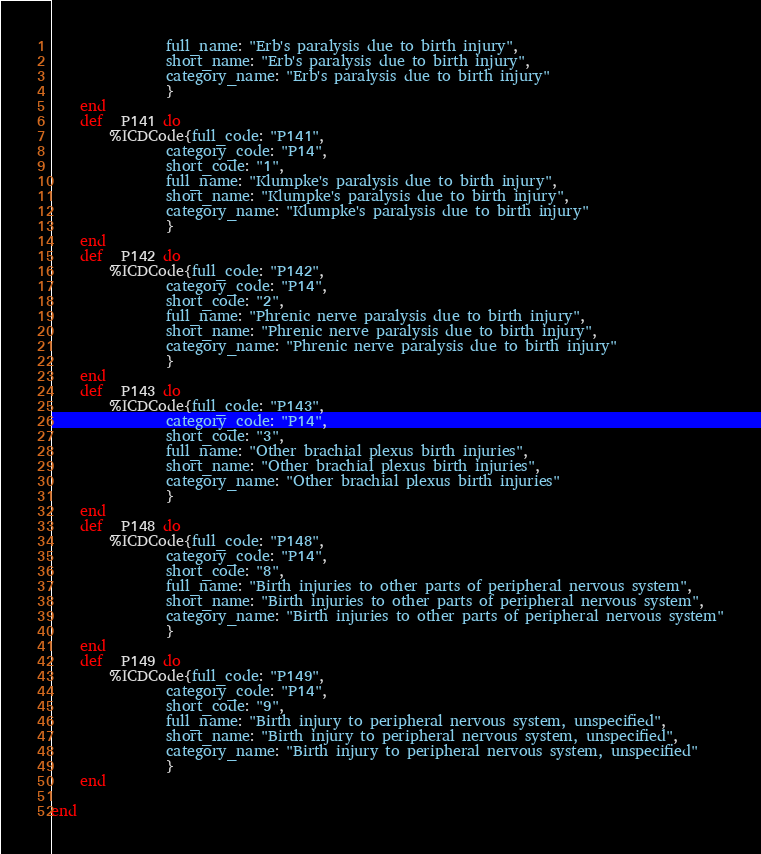Convert code to text. <code><loc_0><loc_0><loc_500><loc_500><_Elixir_>        		full_name: "Erb's paralysis due to birth injury",
        		short_name: "Erb's paralysis due to birth injury",
        		category_name: "Erb's paralysis due to birth injury"
        		}
	end
	def _P141 do 
		%ICDCode{full_code: "P141",
        		category_code: "P14",
        		short_code: "1",
        		full_name: "Klumpke's paralysis due to birth injury",
        		short_name: "Klumpke's paralysis due to birth injury",
        		category_name: "Klumpke's paralysis due to birth injury"
        		}
	end
	def _P142 do 
		%ICDCode{full_code: "P142",
        		category_code: "P14",
        		short_code: "2",
        		full_name: "Phrenic nerve paralysis due to birth injury",
        		short_name: "Phrenic nerve paralysis due to birth injury",
        		category_name: "Phrenic nerve paralysis due to birth injury"
        		}
	end
	def _P143 do 
		%ICDCode{full_code: "P143",
        		category_code: "P14",
        		short_code: "3",
        		full_name: "Other brachial plexus birth injuries",
        		short_name: "Other brachial plexus birth injuries",
        		category_name: "Other brachial plexus birth injuries"
        		}
	end
	def _P148 do 
		%ICDCode{full_code: "P148",
        		category_code: "P14",
        		short_code: "8",
        		full_name: "Birth injuries to other parts of peripheral nervous system",
        		short_name: "Birth injuries to other parts of peripheral nervous system",
        		category_name: "Birth injuries to other parts of peripheral nervous system"
        		}
	end
	def _P149 do 
		%ICDCode{full_code: "P149",
        		category_code: "P14",
        		short_code: "9",
        		full_name: "Birth injury to peripheral nervous system, unspecified",
        		short_name: "Birth injury to peripheral nervous system, unspecified",
        		category_name: "Birth injury to peripheral nervous system, unspecified"
        		}
	end

end
</code> 